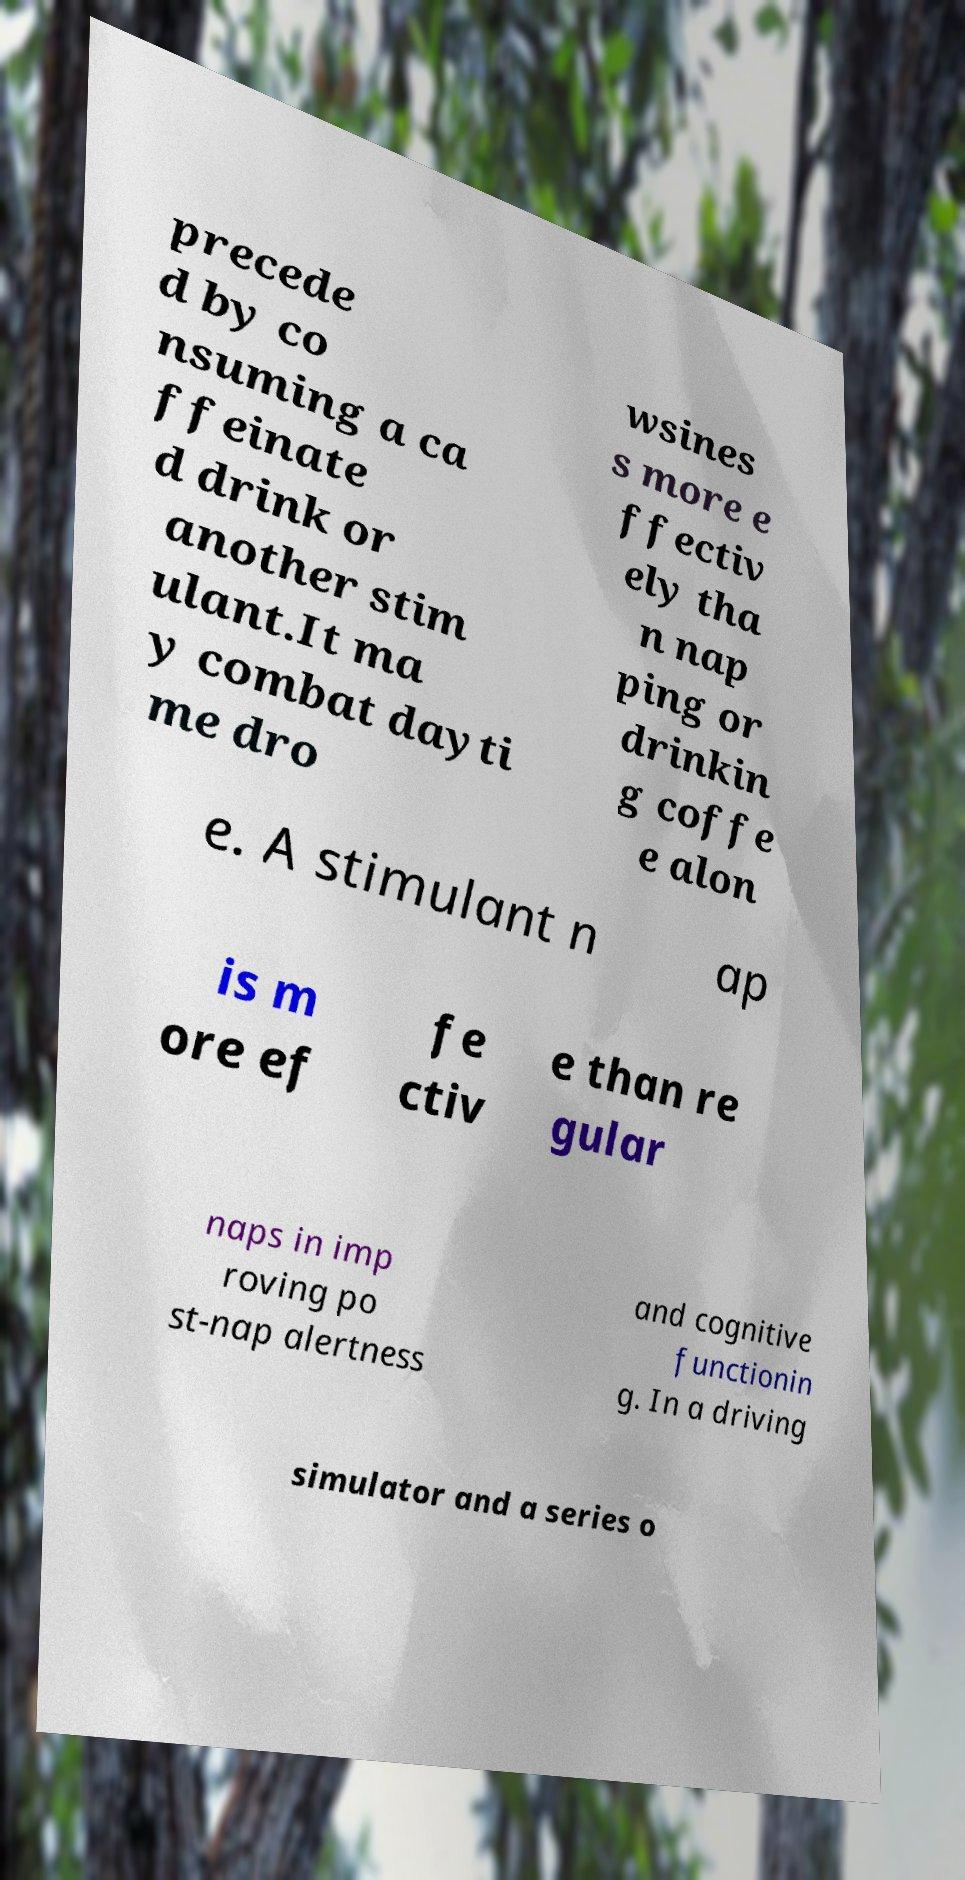Can you read and provide the text displayed in the image?This photo seems to have some interesting text. Can you extract and type it out for me? precede d by co nsuming a ca ffeinate d drink or another stim ulant.It ma y combat dayti me dro wsines s more e ffectiv ely tha n nap ping or drinkin g coffe e alon e. A stimulant n ap is m ore ef fe ctiv e than re gular naps in imp roving po st-nap alertness and cognitive functionin g. In a driving simulator and a series o 